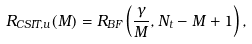<formula> <loc_0><loc_0><loc_500><loc_500>R _ { C S I T , u } ( M ) = R _ { B F } \left ( \frac { \gamma } { M } , N _ { t } - M + 1 \right ) ,</formula> 